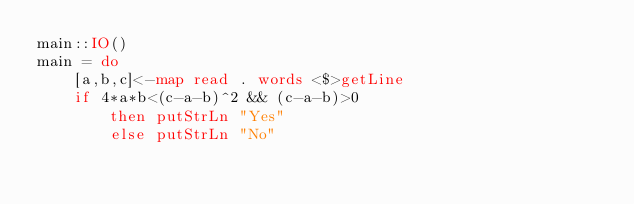Convert code to text. <code><loc_0><loc_0><loc_500><loc_500><_Haskell_>main::IO()
main = do
    [a,b,c]<-map read . words <$>getLine
    if 4*a*b<(c-a-b)^2 && (c-a-b)>0
        then putStrLn "Yes"
        else putStrLn "No"
</code> 